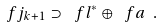Convert formula to latex. <formula><loc_0><loc_0><loc_500><loc_500>\ f j _ { k + 1 } \supset \ f l ^ { * } \oplus \ f a \ .</formula> 